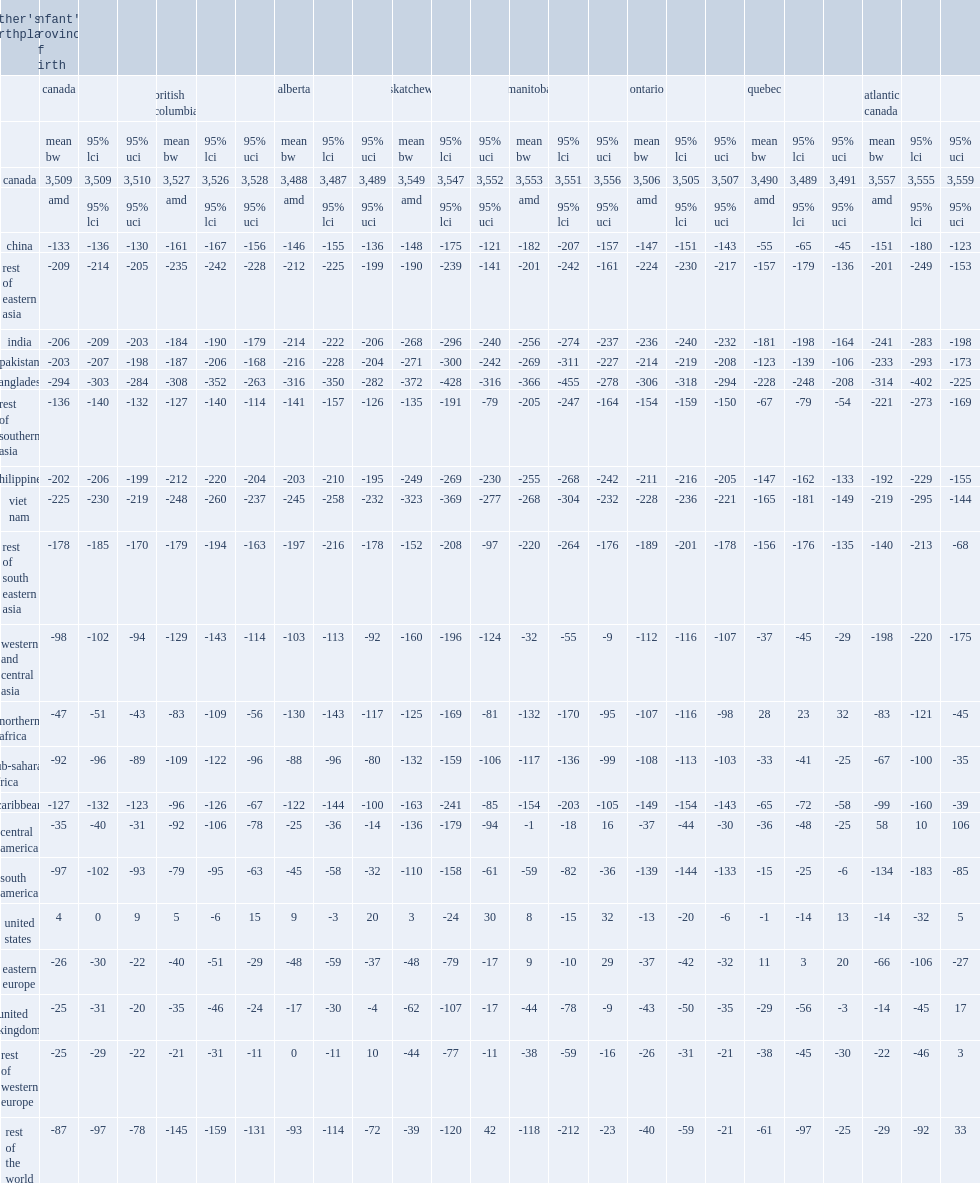How many grams were the mean birth weights among infants born to mothers from united kingdom lower than among infants born to canadian-born mothers? 25. How many grams were the mean birth weights among infants born to mothers from bangladesh lower than among infants born to canadian-born mothers? 294. How many grams were the mean birth weights among infants born to mothers from united states lower than among infants born to canadian-born mothers when infant's province of birth was ontario? 13. How many grams were the mean birth weights among infants born to mothers from northern africa higher than among infants born to canadian-born mothers when infant's province of birth was quebec? 28.0. How many grams were the mean birth weights among infants born to mothers from eastern europe higher than among infants born to canadian-born mothers when infant's province of birth was quebec? 11.0. How many grams were the mean birth weights among infants born to mothers from central america higher than among infants born to canadian-born mothers when infant's province of birth was atlantic canada? 58.0. 